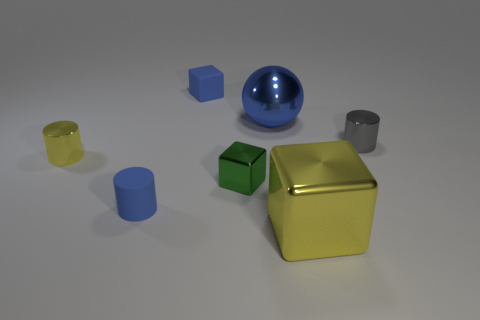Add 2 small gray metallic objects. How many objects exist? 9 Subtract all spheres. How many objects are left? 6 Add 6 green shiny things. How many green shiny things exist? 7 Subtract 1 blue blocks. How many objects are left? 6 Subtract all red objects. Subtract all green metallic blocks. How many objects are left? 6 Add 6 spheres. How many spheres are left? 7 